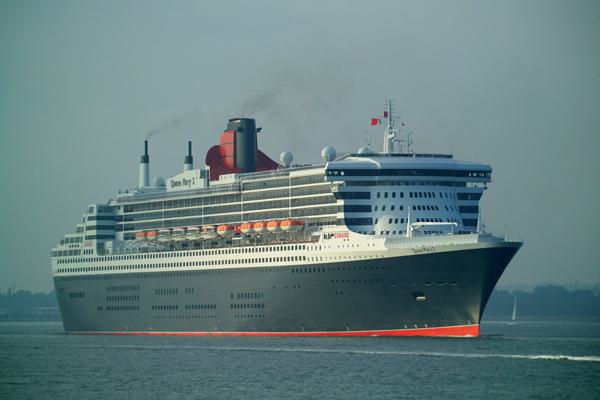What is the environment like around the ship? The ship is cruising on what appears to be calm water, likely a sea or ocean. The sky is overcast, suggesting cloudy weather, yet there's ample daylight that highlights the ship's profile. There is no land in sight, implying this vessel is out in open water, possibly on a course between destinations. 